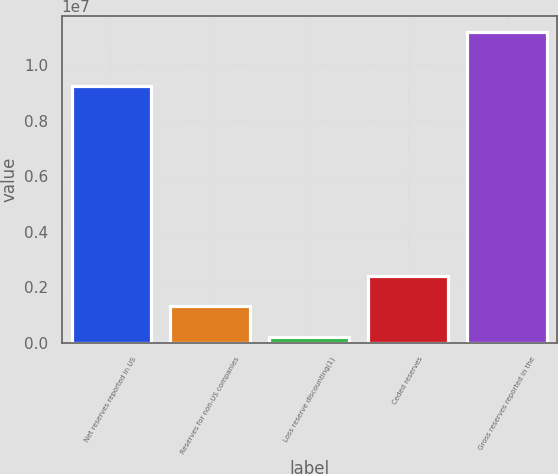Convert chart to OTSL. <chart><loc_0><loc_0><loc_500><loc_500><bar_chart><fcel>Net reserves reported in US<fcel>Reserves for non-US companies<fcel>Loss reserve discounting(1)<fcel>Ceded reserves<fcel>Gross reserves reported in the<nl><fcel>9.23521e+06<fcel>1.31367e+06<fcel>215502<fcel>2.41184e+06<fcel>1.11972e+07<nl></chart> 